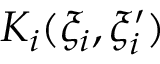<formula> <loc_0><loc_0><loc_500><loc_500>K _ { i } ( \xi _ { i } , \xi _ { i } ^ { \prime } )</formula> 